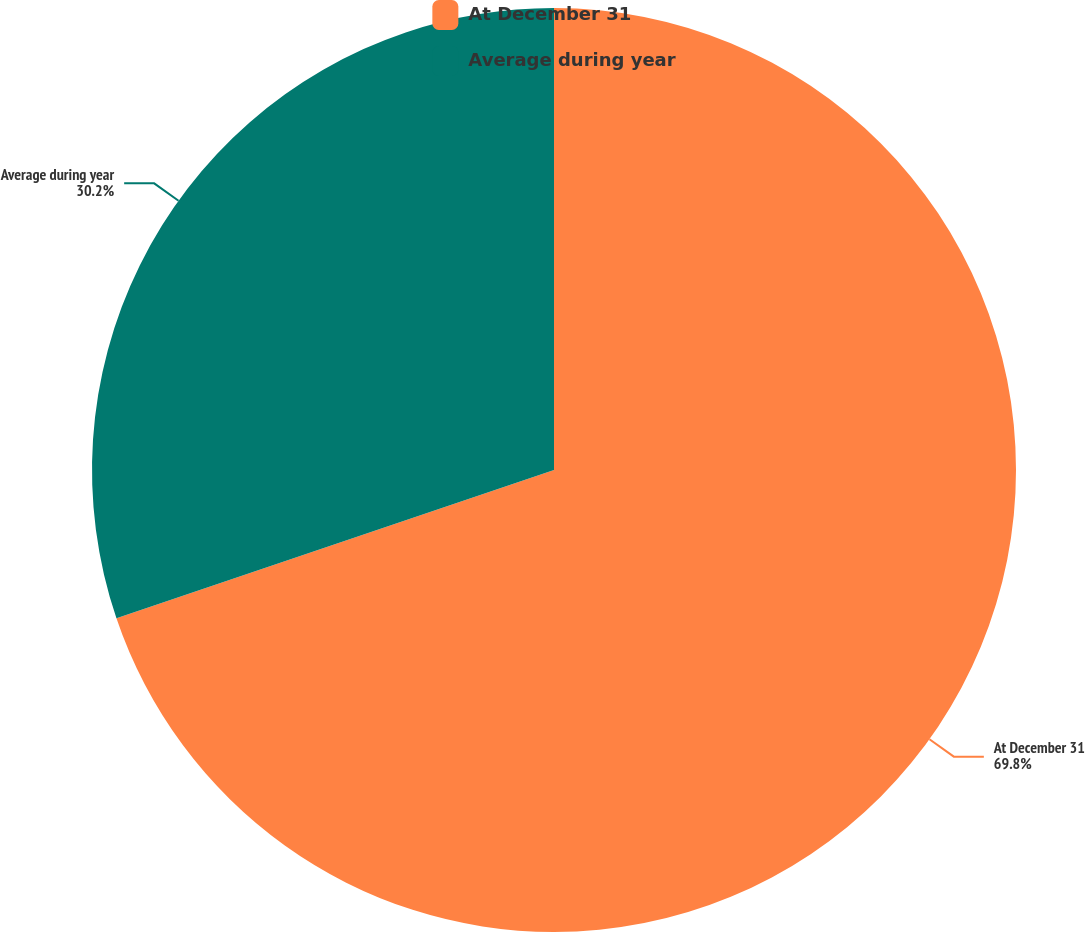Convert chart to OTSL. <chart><loc_0><loc_0><loc_500><loc_500><pie_chart><fcel>At December 31<fcel>Average during year<nl><fcel>69.8%<fcel>30.2%<nl></chart> 